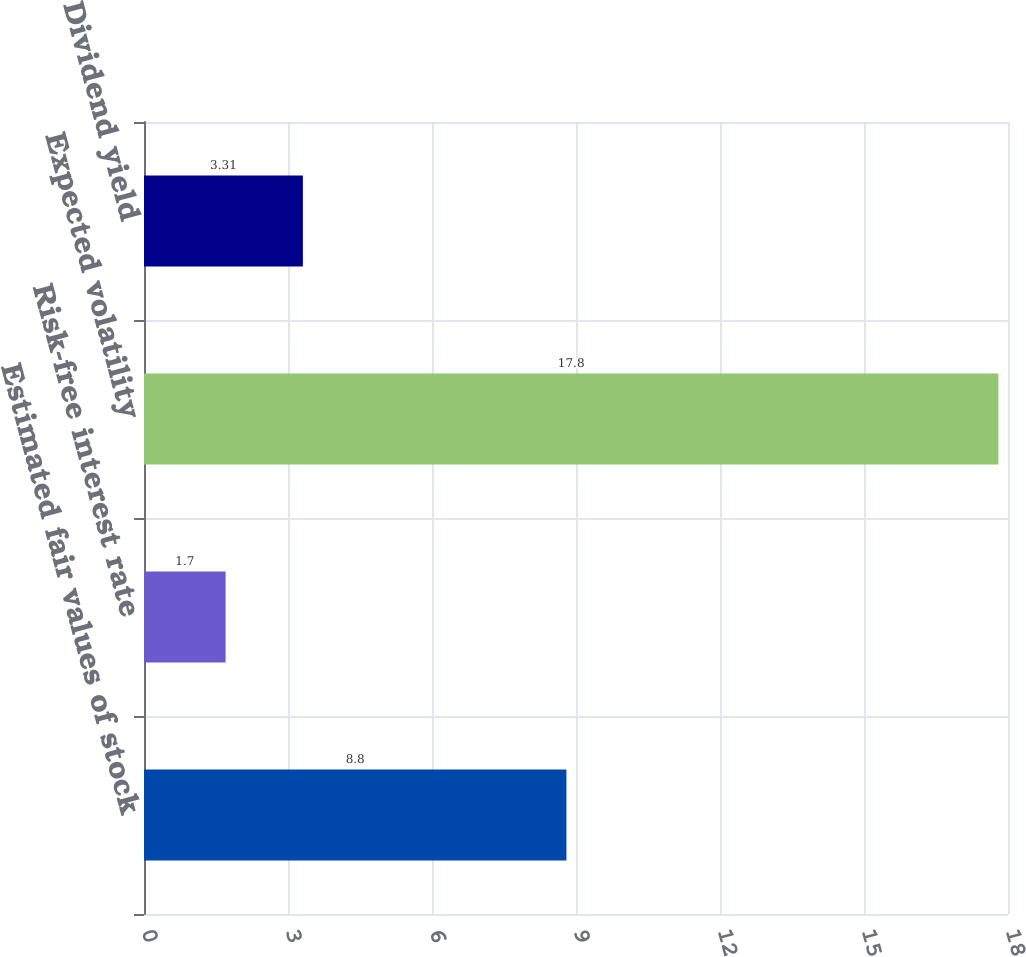Convert chart to OTSL. <chart><loc_0><loc_0><loc_500><loc_500><bar_chart><fcel>Estimated fair values of stock<fcel>Risk-free interest rate<fcel>Expected volatility<fcel>Dividend yield<nl><fcel>8.8<fcel>1.7<fcel>17.8<fcel>3.31<nl></chart> 